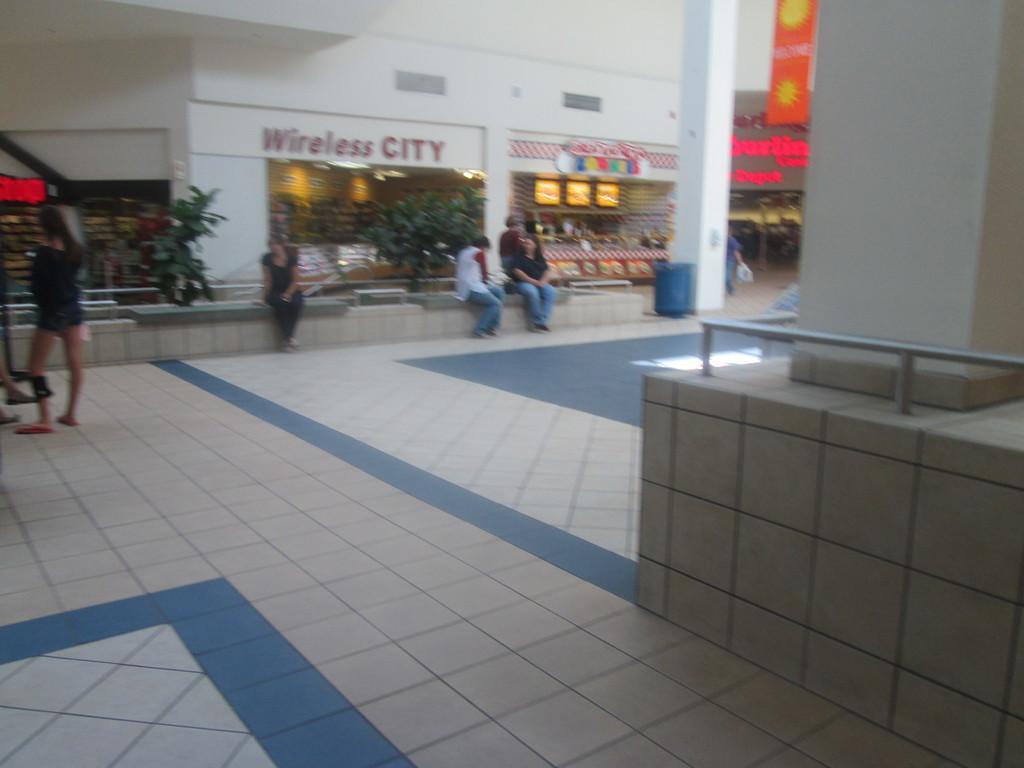Can you describe this image briefly? In this image we can see group of people sitting on the wall. One woman is standing on the floor. In the background we can see group of plants and building. 